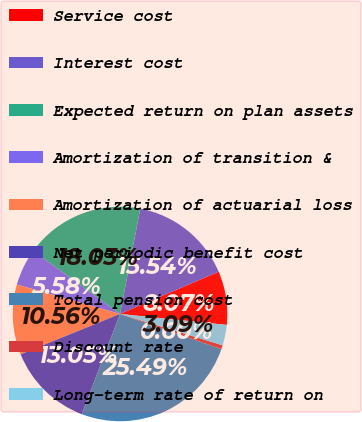<chart> <loc_0><loc_0><loc_500><loc_500><pie_chart><fcel>Service cost<fcel>Interest cost<fcel>Expected return on plan assets<fcel>Amortization of transition &<fcel>Amortization of actuarial loss<fcel>Net periodic benefit cost<fcel>Total pension cost<fcel>Discount rate<fcel>Long-term rate of return on<nl><fcel>8.07%<fcel>15.54%<fcel>18.03%<fcel>5.58%<fcel>10.56%<fcel>13.05%<fcel>25.49%<fcel>0.6%<fcel>3.09%<nl></chart> 